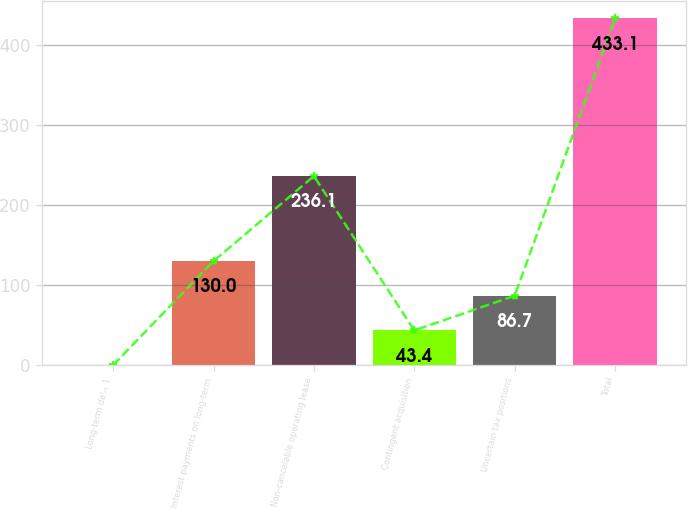Convert chart to OTSL. <chart><loc_0><loc_0><loc_500><loc_500><bar_chart><fcel>Long-term debt 1<fcel>Interest payments on long-term<fcel>Non-cancelable operating lease<fcel>Contingent acquisition<fcel>Uncertain tax positions<fcel>Total<nl><fcel>0.1<fcel>130<fcel>236.1<fcel>43.4<fcel>86.7<fcel>433.1<nl></chart> 